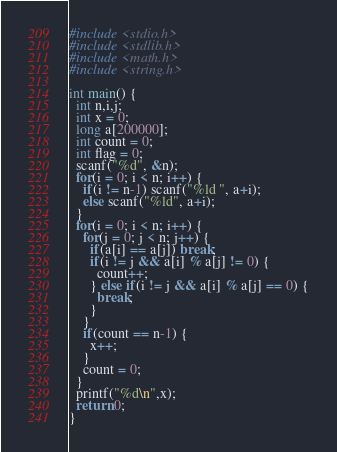<code> <loc_0><loc_0><loc_500><loc_500><_C_>#include <stdio.h>
#include <stdlib.h>
#include <math.h>
#include <string.h>

int main() {
  int n,i,j;
  int x = 0;
  long a[200000];
  int count = 0;
  int flag = 0;
  scanf("%d", &n);
  for(i = 0; i < n; i++) {
    if(i != n-1) scanf("%ld ", a+i);
    else scanf("%ld", a+i);
  }
  for(i = 0; i < n; i++) {
    for(j = 0; j < n; j++) {
      if(a[i] == a[j]) break;
      if(i != j && a[i] % a[j] != 0) {
        count++;
      } else if(i != j && a[i] % a[j] == 0) {
        break;
      }
    }
    if(count == n-1) {
      x++;
    }
    count = 0;
  }
  printf("%d\n",x);
  return 0;
}
</code> 